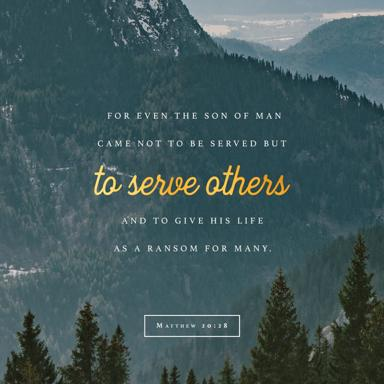What does the text in the image say? The image features the quote, 'For even the Son of Man came not to be served but to serve others and to give his life as a ransom for many.' This passage is from the Bible, specifically Matthew 20:28. 